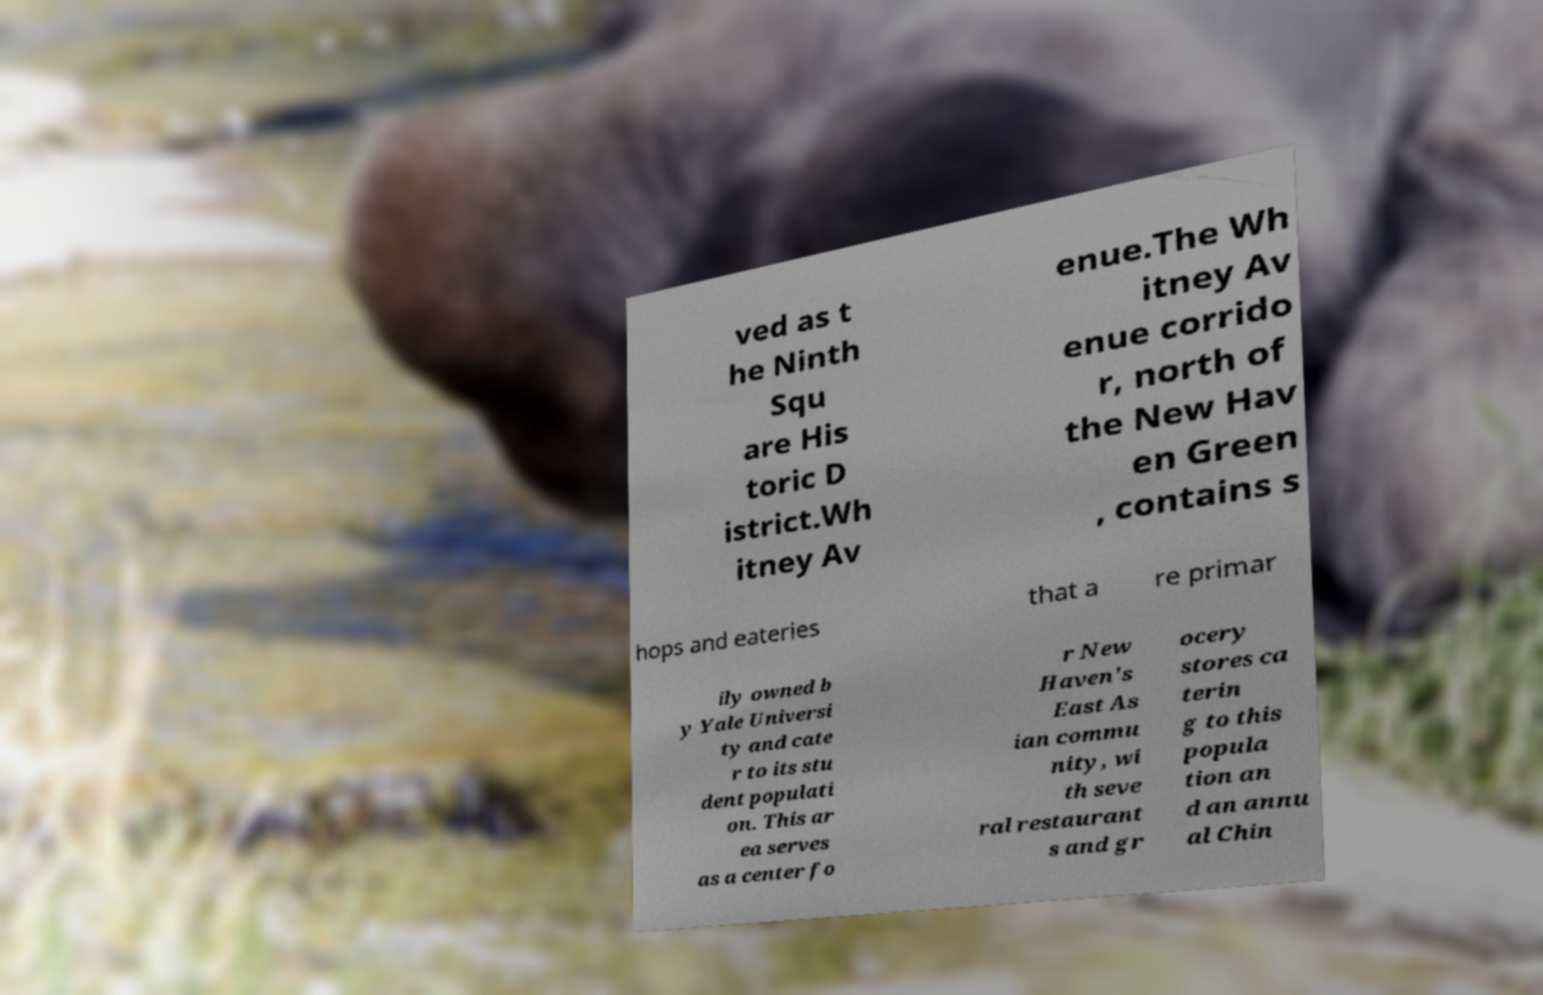Can you accurately transcribe the text from the provided image for me? ved as t he Ninth Squ are His toric D istrict.Wh itney Av enue.The Wh itney Av enue corrido r, north of the New Hav en Green , contains s hops and eateries that a re primar ily owned b y Yale Universi ty and cate r to its stu dent populati on. This ar ea serves as a center fo r New Haven's East As ian commu nity, wi th seve ral restaurant s and gr ocery stores ca terin g to this popula tion an d an annu al Chin 